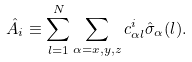Convert formula to latex. <formula><loc_0><loc_0><loc_500><loc_500>\hat { A } _ { i } \equiv \sum _ { l = 1 } ^ { N } \sum _ { \alpha = x , y , z } c _ { \alpha l } ^ { i } \hat { \sigma } _ { \alpha } ( l ) .</formula> 